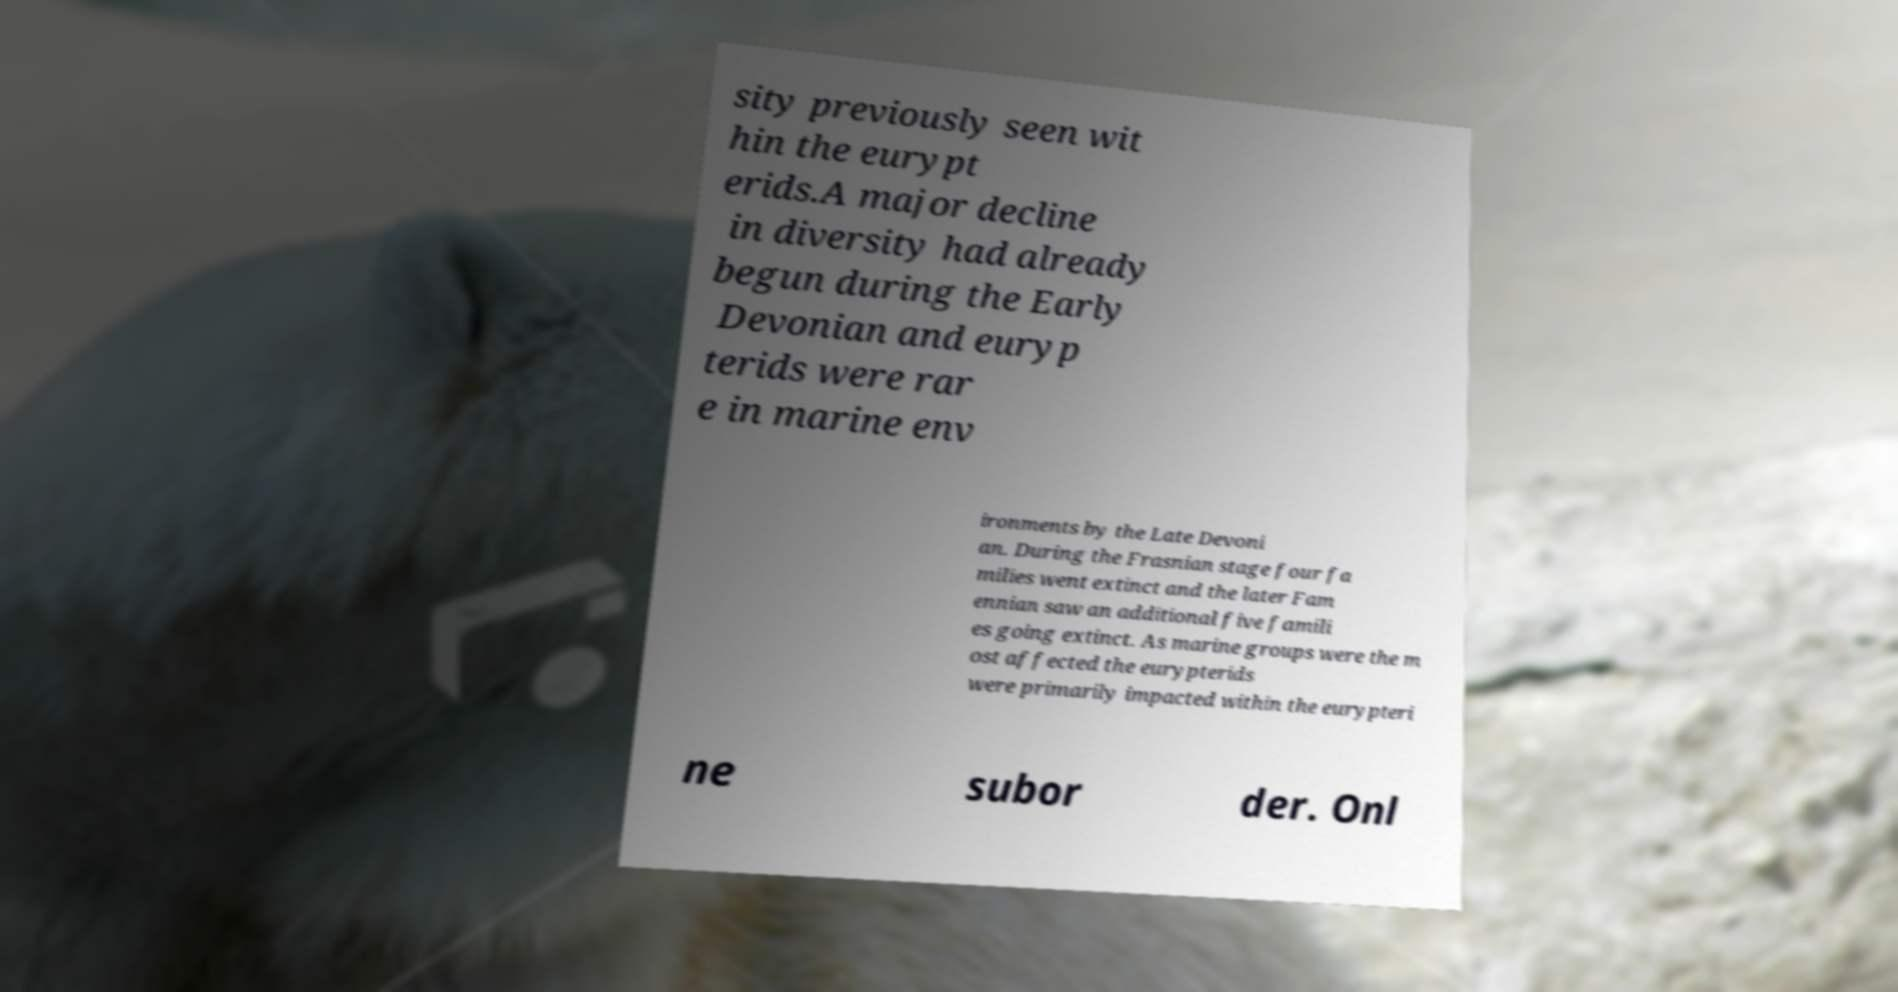Could you extract and type out the text from this image? sity previously seen wit hin the eurypt erids.A major decline in diversity had already begun during the Early Devonian and euryp terids were rar e in marine env ironments by the Late Devoni an. During the Frasnian stage four fa milies went extinct and the later Fam ennian saw an additional five famili es going extinct. As marine groups were the m ost affected the eurypterids were primarily impacted within the eurypteri ne subor der. Onl 